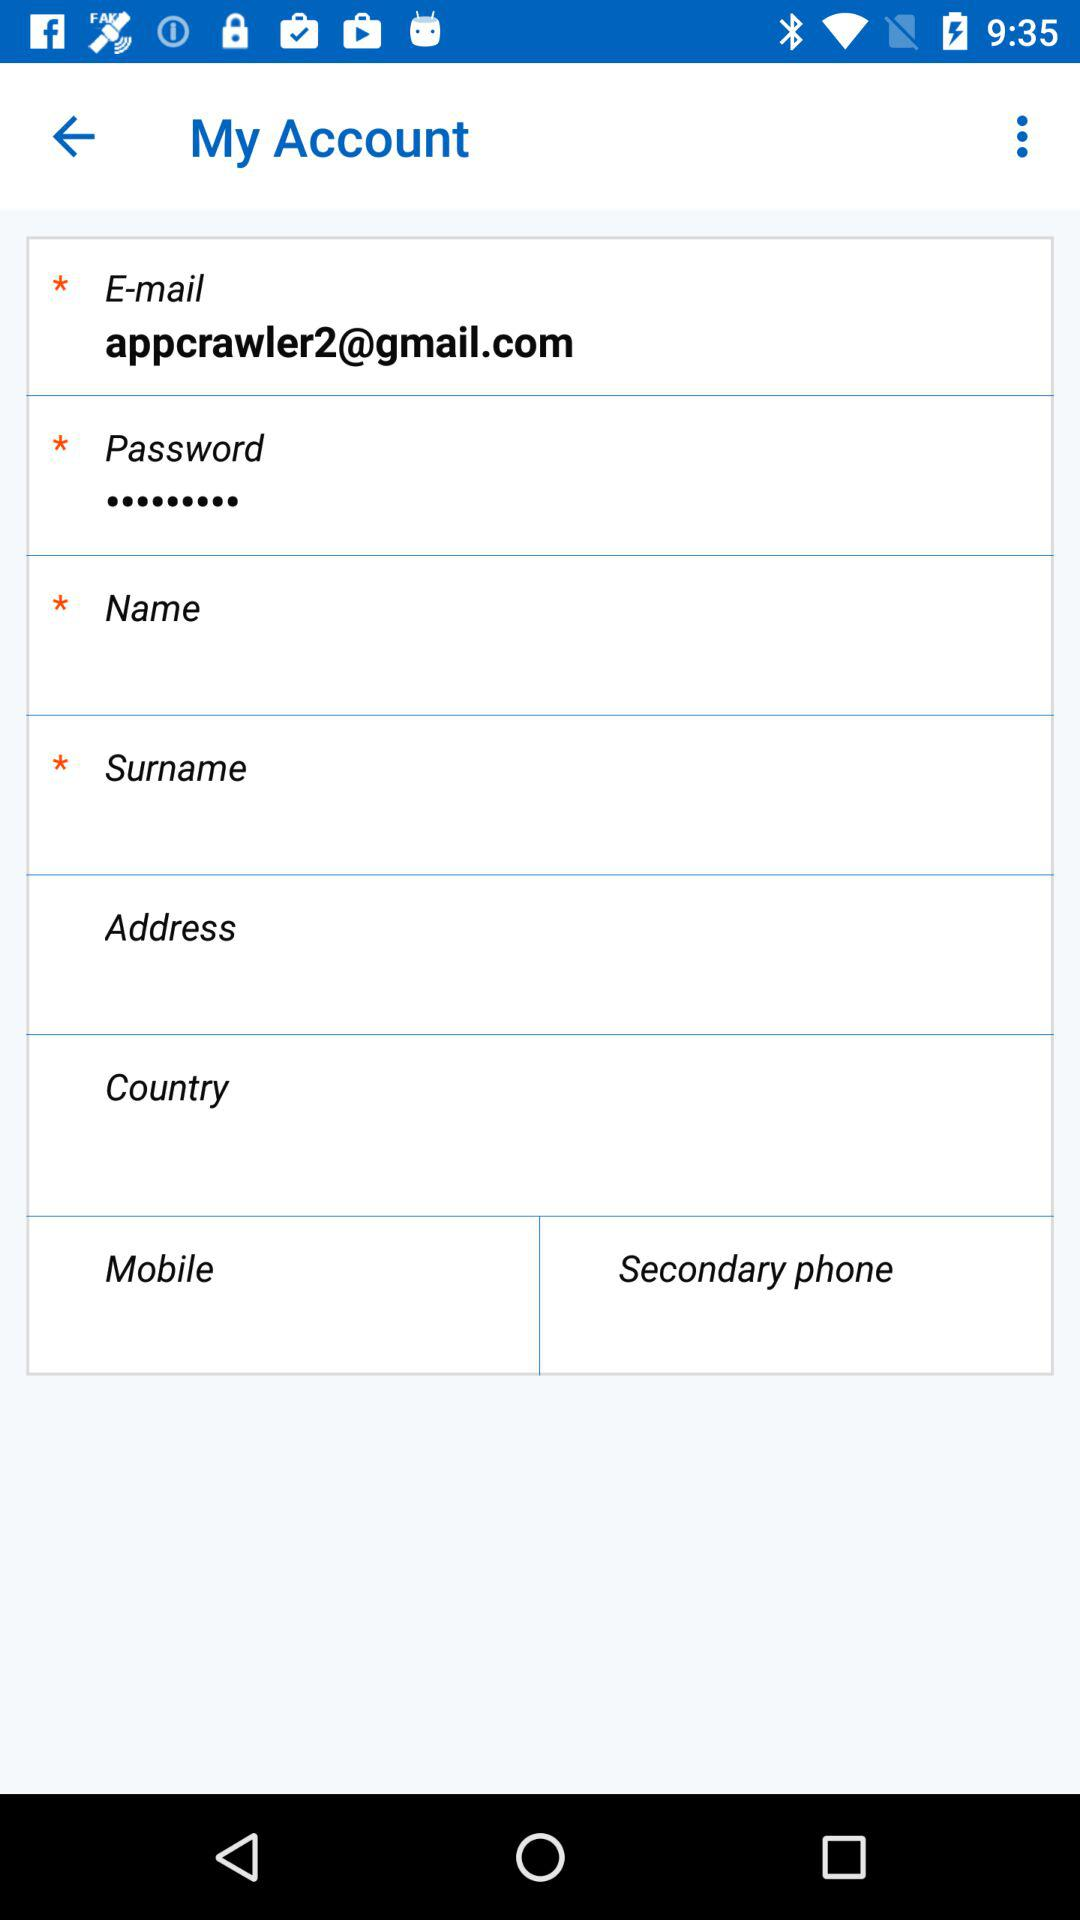What is the email address? The email address is appcrawler2@gmail.com. 